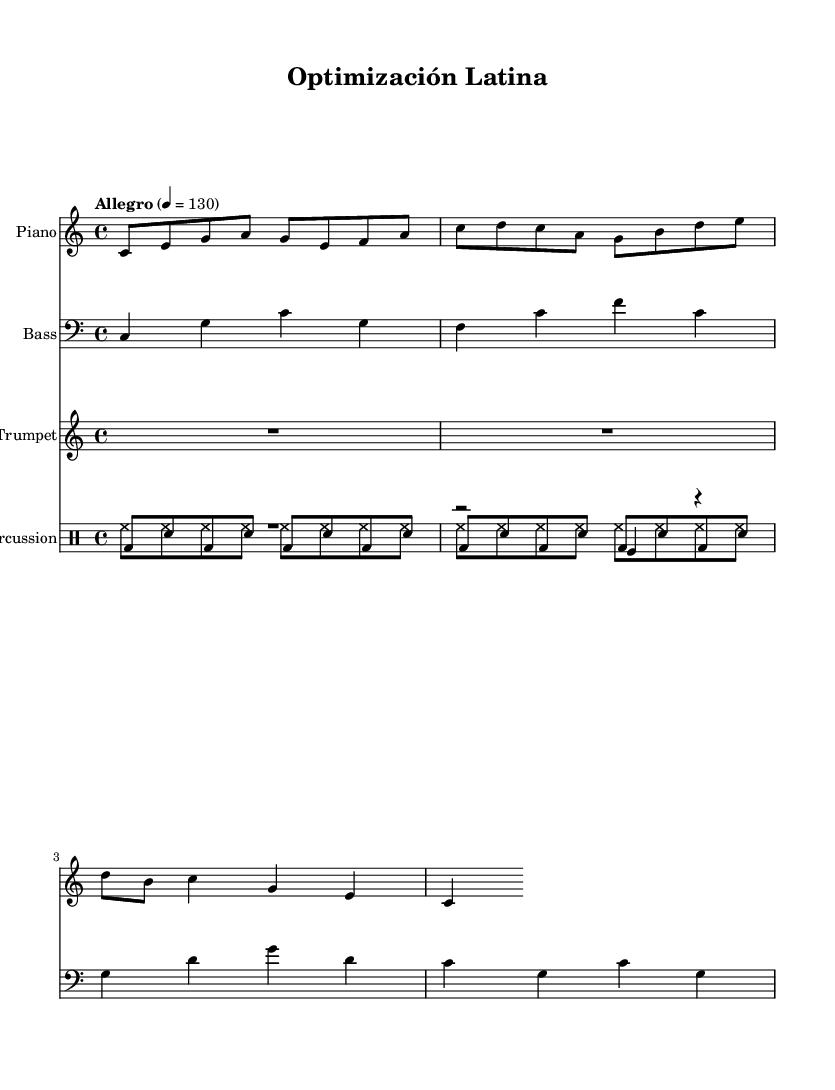What is the key signature of this music? The key signature indicated at the beginning of the score shows no sharps or flats, which represents C major.
Answer: C major What is the time signature of the piece? The time signature is shown at the beginning of the score as 4/4, which indicates four beats per measure.
Answer: 4/4 What is the tempo marking for this music? The tempo marking specifies "Allegro" with a beat of 130, indicating a fast tempo.
Answer: Allegro, 130 How many measures are in the piano part? By counting the measures presented in the piano part, there are a total of 4 measures (the score contains two sets of 2 measures when analyzing the repeated parts).
Answer: 4 Which drum instrument has a rest followed by a tom fill in its part? The timbales part includes a rest (R1) followed by a tom fill (tomfl4).
Answer: Timbales What is the rhythmic pattern for the congas? The rhythm for the congas consists of alternating bass drum (bd) and snare (sn) hits, following the specified eight-note pattern.
Answer: bd sn Which instrument is indicated at the top of the first staff? The first staff is identified as "Piano" in the score heading above it, indicating it's the main melodic instrument.
Answer: Piano 